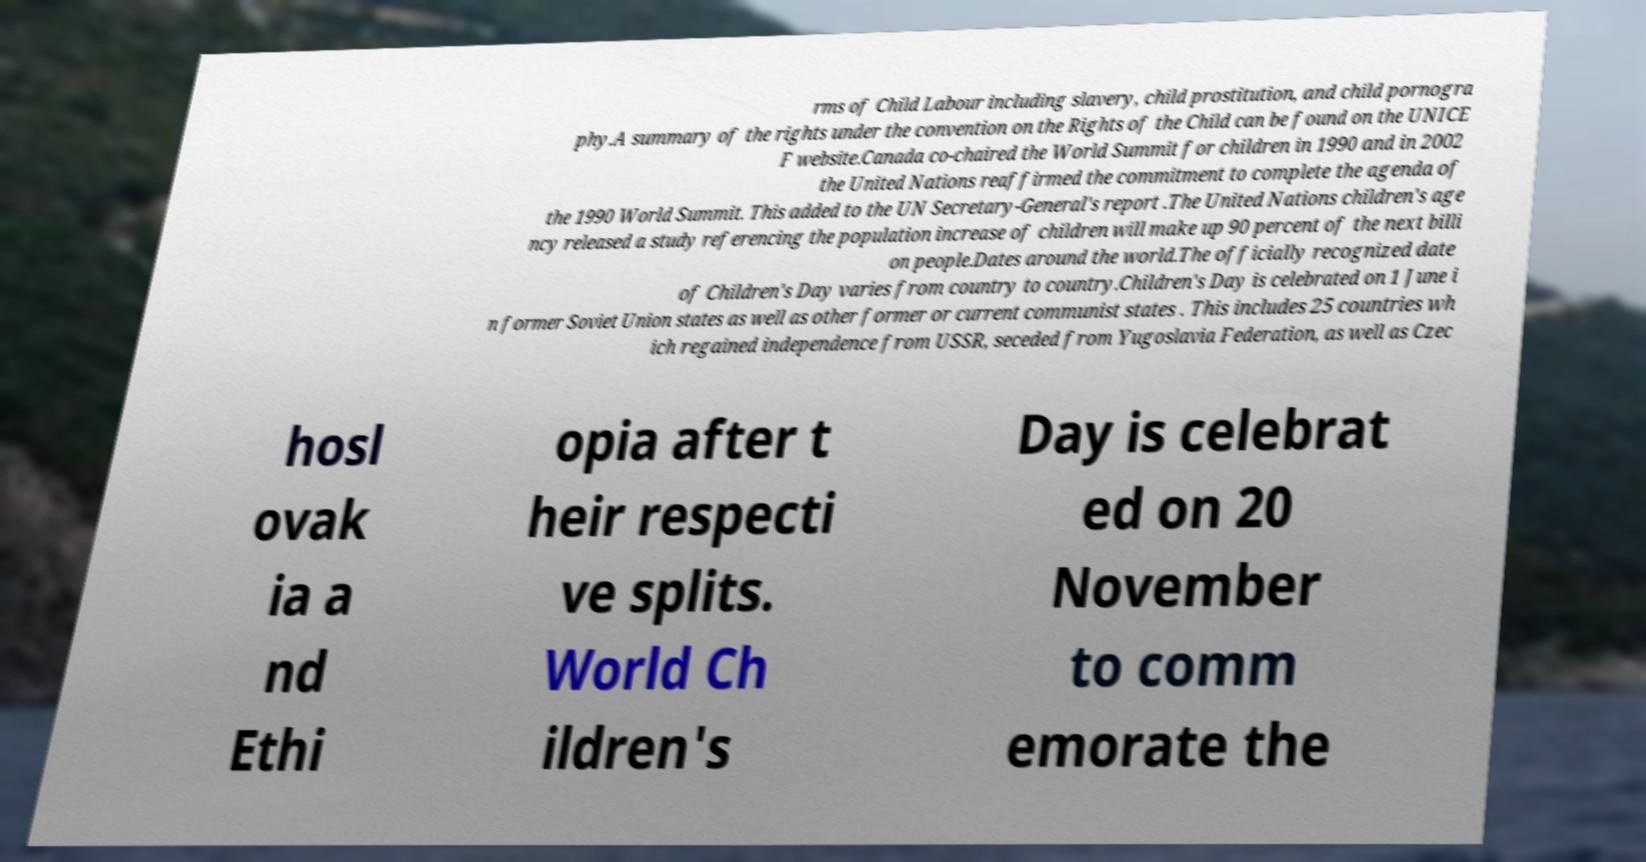For documentation purposes, I need the text within this image transcribed. Could you provide that? rms of Child Labour including slavery, child prostitution, and child pornogra phy.A summary of the rights under the convention on the Rights of the Child can be found on the UNICE F website.Canada co-chaired the World Summit for children in 1990 and in 2002 the United Nations reaffirmed the commitment to complete the agenda of the 1990 World Summit. This added to the UN Secretary-General's report .The United Nations children's age ncy released a study referencing the population increase of children will make up 90 percent of the next billi on people.Dates around the world.The officially recognized date of Children's Day varies from country to country.Children's Day is celebrated on 1 June i n former Soviet Union states as well as other former or current communist states . This includes 25 countries wh ich regained independence from USSR, seceded from Yugoslavia Federation, as well as Czec hosl ovak ia a nd Ethi opia after t heir respecti ve splits. World Ch ildren's Day is celebrat ed on 20 November to comm emorate the 